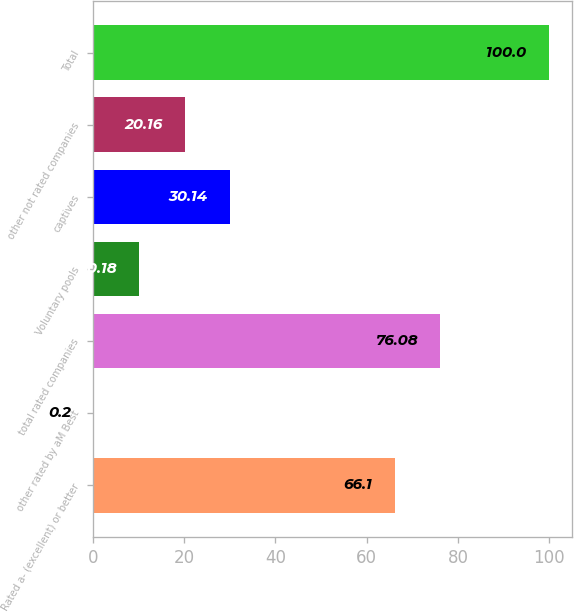Convert chart to OTSL. <chart><loc_0><loc_0><loc_500><loc_500><bar_chart><fcel>Rated a- (excellent) or better<fcel>other rated by aM Best<fcel>total rated companies<fcel>Voluntary pools<fcel>captives<fcel>other not rated companies<fcel>Total<nl><fcel>66.1<fcel>0.2<fcel>76.08<fcel>10.18<fcel>30.14<fcel>20.16<fcel>100<nl></chart> 